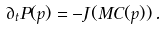<formula> <loc_0><loc_0><loc_500><loc_500>\partial _ { t } P ( p ) = - J ( { M C } ( p ) ) \, .</formula> 